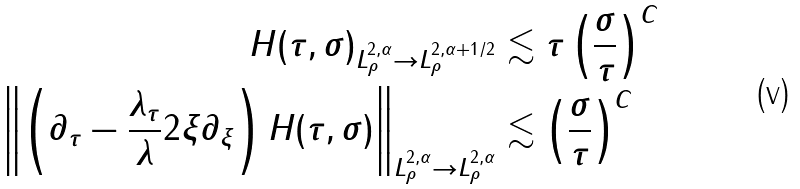Convert formula to latex. <formula><loc_0><loc_0><loc_500><loc_500>\| H ( \tau , \sigma ) \| _ { L ^ { 2 , \alpha } _ { \rho } \to L ^ { 2 , \alpha + 1 / 2 } _ { \rho } } & \lesssim \tau \left ( \frac { \sigma } { \tau } \right ) ^ { C } \\ \left \| \left ( \partial _ { \tau } - \frac { \lambda _ { \tau } } { \lambda } 2 \xi \partial _ { \xi } \right ) H ( \tau , \sigma ) \right \| _ { L ^ { 2 , \alpha } _ { \rho } \to L ^ { 2 , \alpha } _ { \rho } } & \lesssim \left ( \frac { \sigma } { \tau } \right ) ^ { C }</formula> 